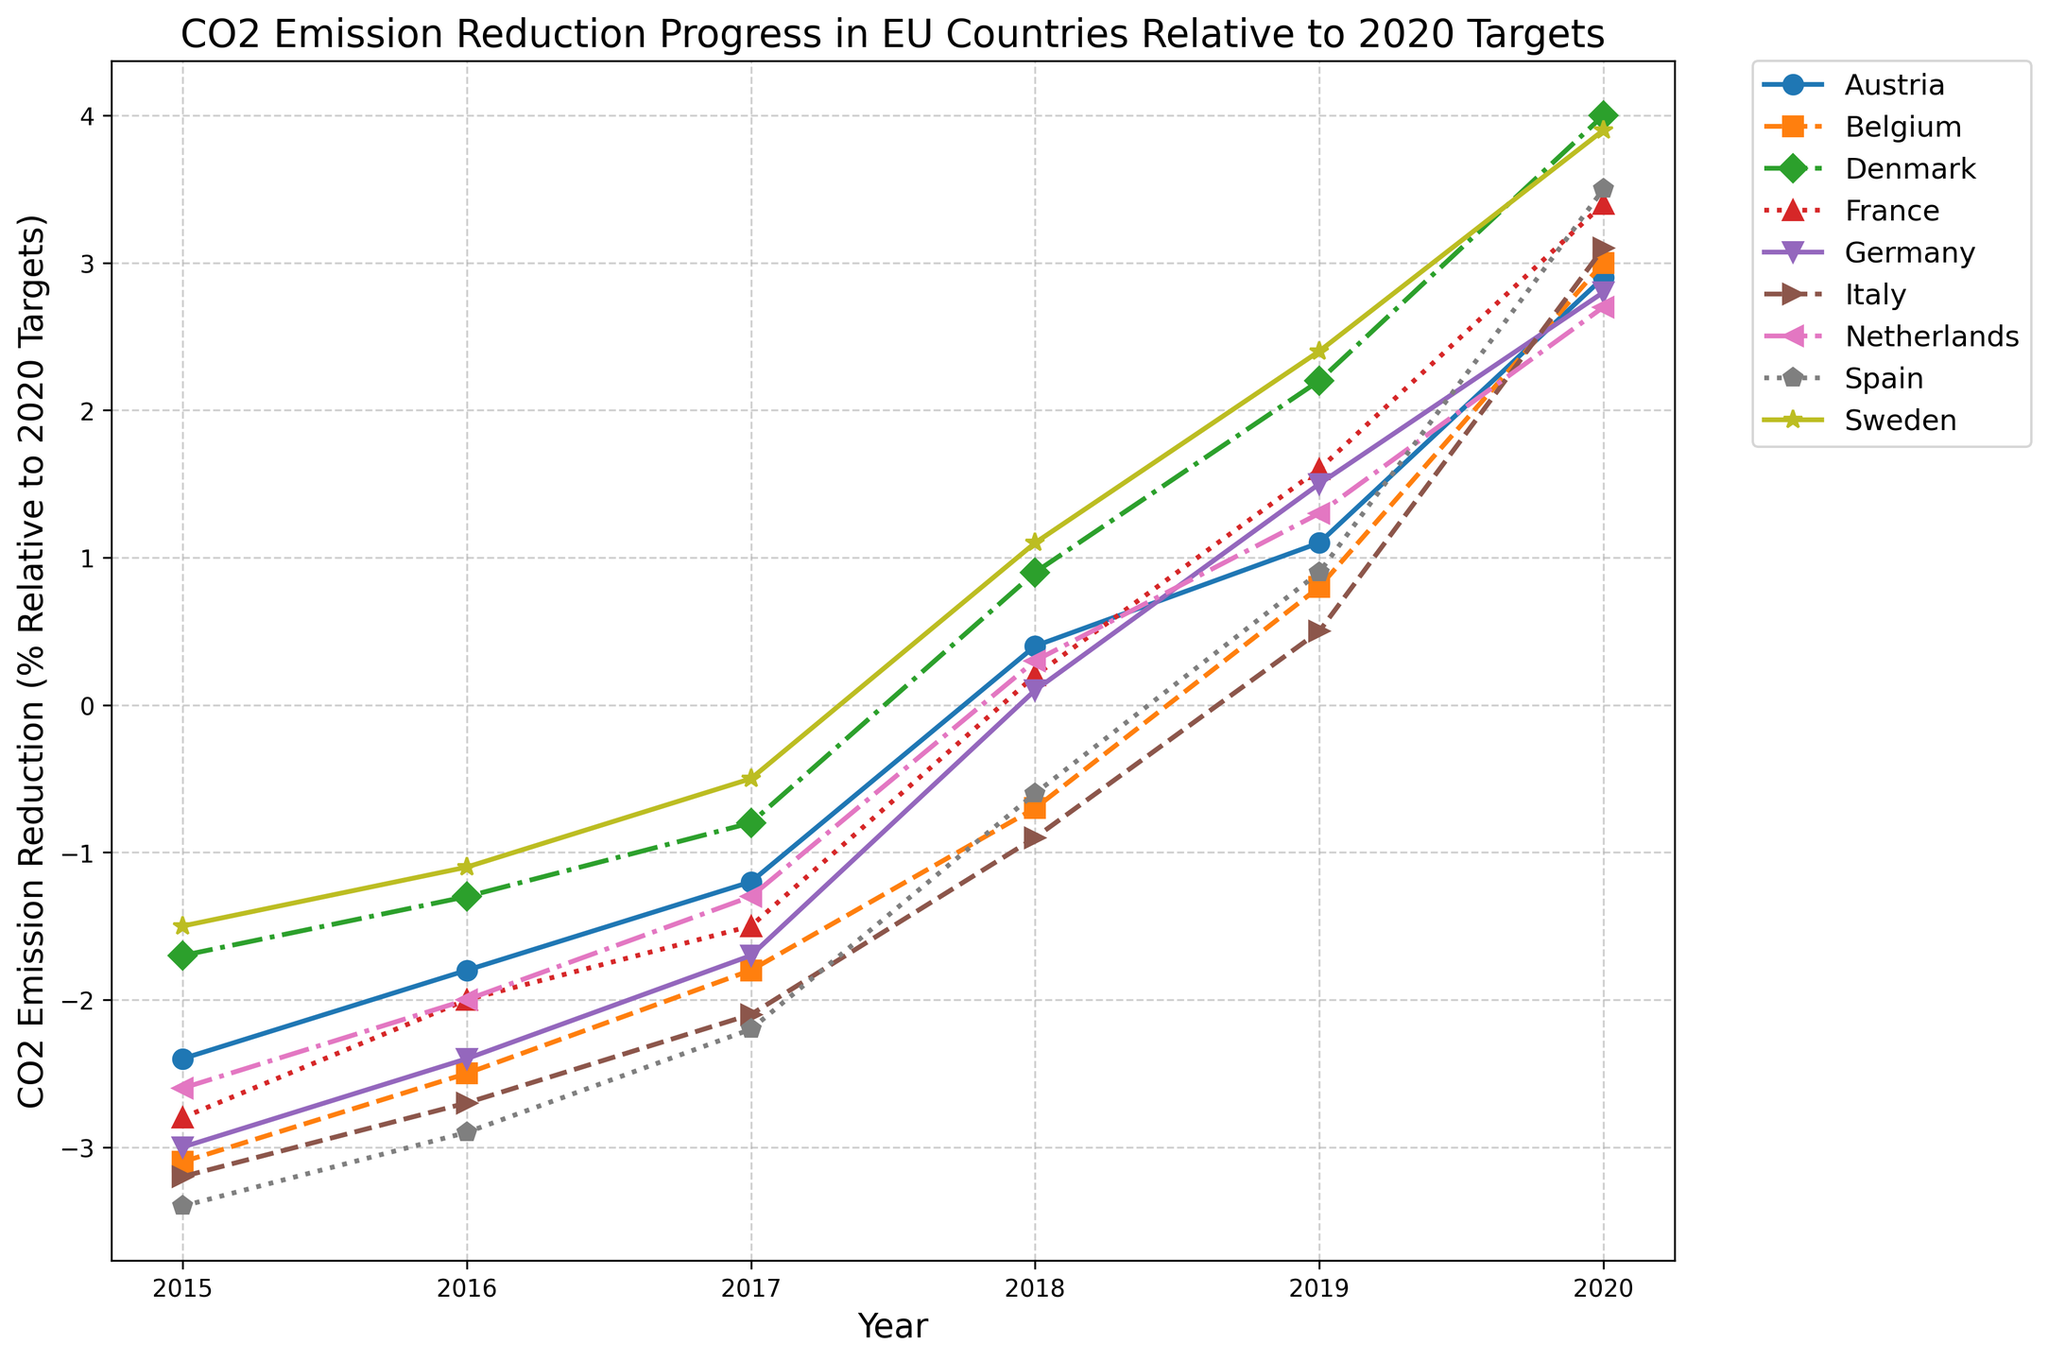Which country showed the highest CO2 emission reduction by 2020? To determine the highest reduction, look for the data points in 2020. Denmark shows the highest reduction with 4.0%.
Answer: Denmark Which two countries made the least progress in emission reduction by 2020? Compare the 2020 data for the lowest values. Austria and Netherlands show the least progress with 2.9% and 2.7% reductions, respectively.
Answer: Austria and Netherlands What is the trend in CO2 emission reduction for Germany from 2015 to 2020? Observe the Germany line from 2015 to 2020; it starts at -3.0% in 2015 and increases to 2.8% in 2020, showing a steady upward trend.
Answer: Steady upward trend Which country had the steepest rise in emission reduction from 2019 to 2020? Check the data points from 2019 to 2020 for the steepest slope. Denmark increased from 2.2% to 4.0%, a rise of 1.8%, which is the steepest.
Answer: Denmark Between 2015 and 2017, which country showed the least improvement in emission reduction? Compare the changes in percentage for 2015 to 2017. Belgium decreased only from -3.1% to -1.8%, an improvement of 1.3%, which is the least.
Answer: Belgium For France, what is the difference in CO2 emission reduction between 2018 and 2020? Subtract the 2018 value (0.2%) from the 2020 value (3.4%). The difference is 3.4% - 0.2% = 3.2%.
Answer: 3.2% How does the CO2 reduction progress of Italy in 2019 compare to that of Sweden in 2017? Italy in 2019 has 0.5% reduction, and Sweden in 2017 has -0.5%. Italy's reduction is 1.0% more than Sweden's.
Answer: 1.0% more On average, how much did Austria's CO2 emissions reduce per year between 2015 and 2020? Sum the reductions from 2015 to 2020 (-2.4 + -1.8 + -1.2 + 0.4 + 1.1 + 2.9) and divide by 6. The sum is -1.0, the average is -1.0/6 = approximately -0.17%.
Answer: Approximately -0.17% Compare the emission reductions of Belgium and Spain in 2018. Which country was closer to meeting its 2020 targets? In 2018, Belgium had -0.7% and Spain had -0.6%. Spain is closer by 0.1%.
Answer: Spain What is the average CO2 emission reduction for all countries by 2020? Sum the 2020 values (2.9 + 3.0 + 4.0 + 3.4 + 2.8 + 3.1 + 2.7 + 3.5 + 3.9) and divide by 9. The sum is 29.3, and the average is 29.3/9 = approximately 3.26%.
Answer: Approximately 3.26% 